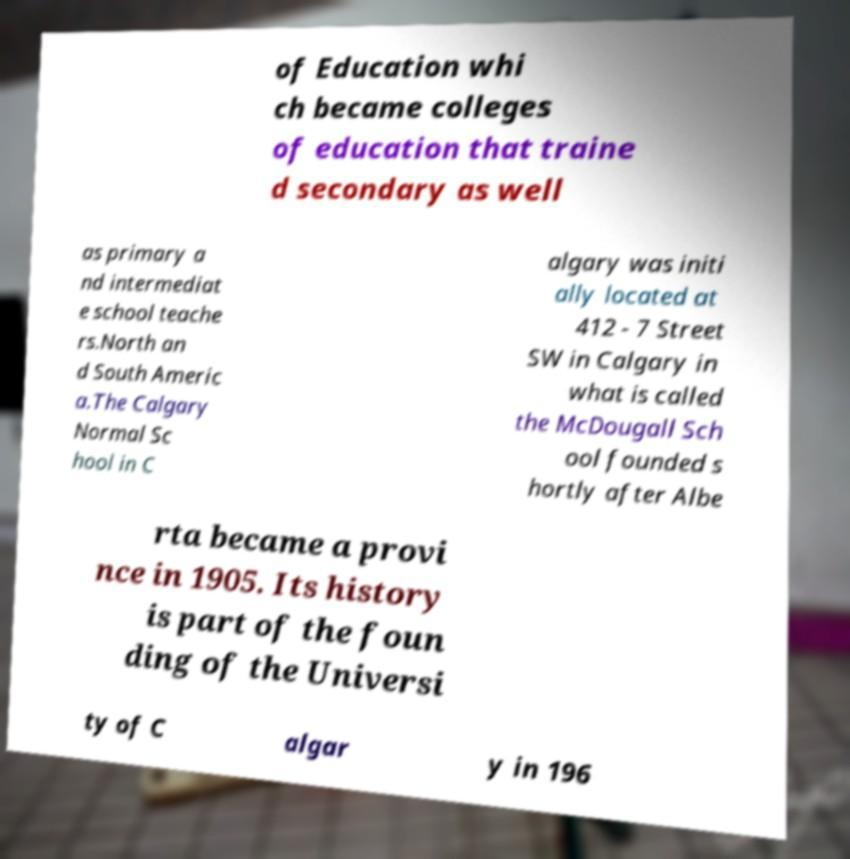Please identify and transcribe the text found in this image. of Education whi ch became colleges of education that traine d secondary as well as primary a nd intermediat e school teache rs.North an d South Americ a.The Calgary Normal Sc hool in C algary was initi ally located at 412 - 7 Street SW in Calgary in what is called the McDougall Sch ool founded s hortly after Albe rta became a provi nce in 1905. Its history is part of the foun ding of the Universi ty of C algar y in 196 